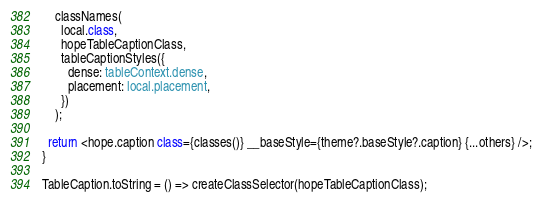<code> <loc_0><loc_0><loc_500><loc_500><_TypeScript_>    classNames(
      local.class,
      hopeTableCaptionClass,
      tableCaptionStyles({
        dense: tableContext.dense,
        placement: local.placement,
      })
    );

  return <hope.caption class={classes()} __baseStyle={theme?.baseStyle?.caption} {...others} />;
}

TableCaption.toString = () => createClassSelector(hopeTableCaptionClass);
</code> 